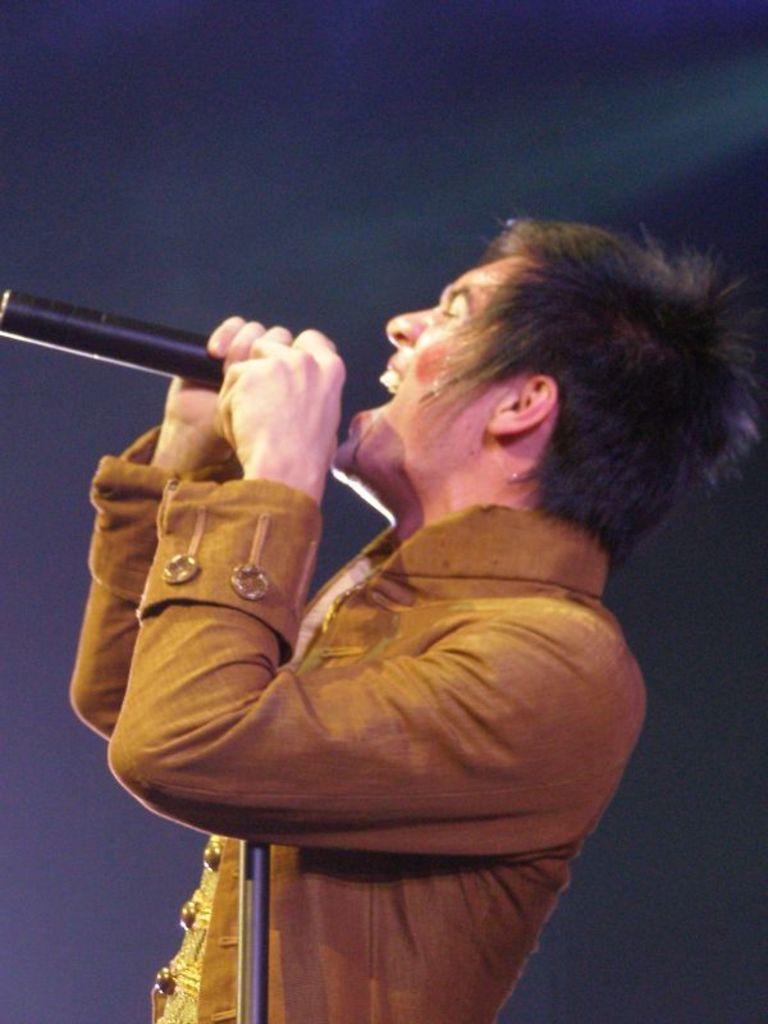In one or two sentences, can you explain what this image depicts? In this image, we can see a person holding a microphone and singing. The background of the image is dark. 